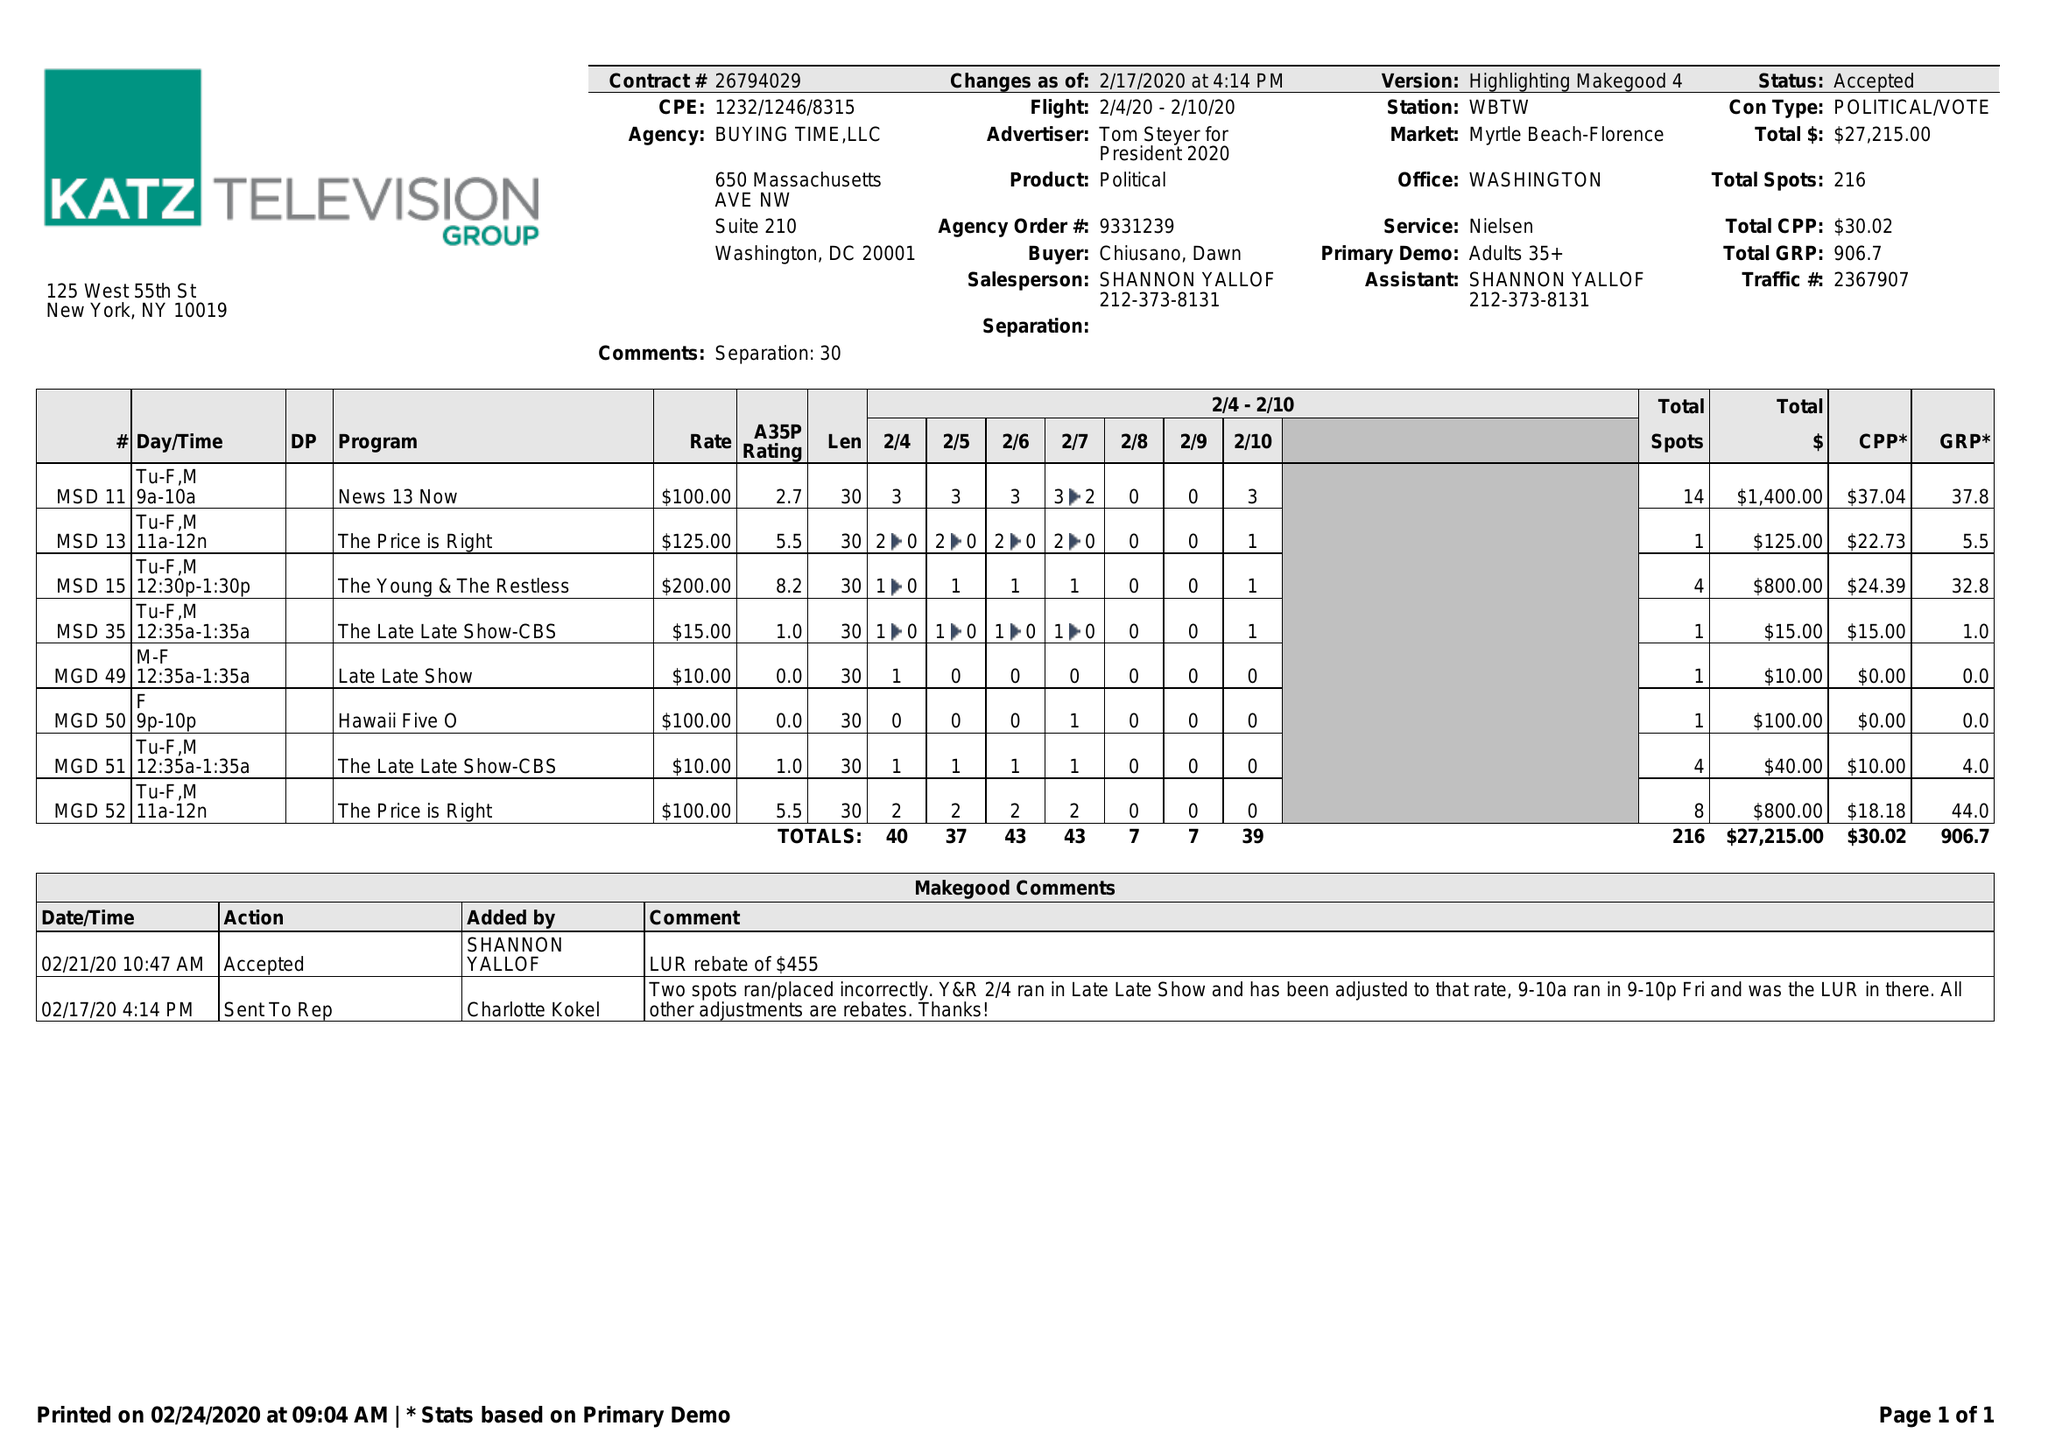What is the value for the contract_num?
Answer the question using a single word or phrase. 26794029 